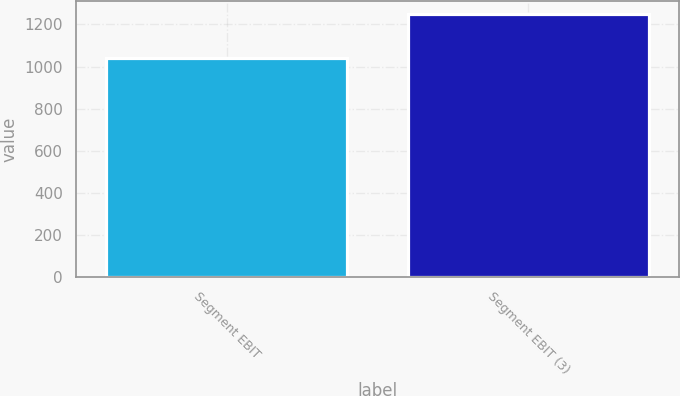<chart> <loc_0><loc_0><loc_500><loc_500><bar_chart><fcel>Segment EBIT<fcel>Segment EBIT (3)<nl><fcel>1041<fcel>1248<nl></chart> 